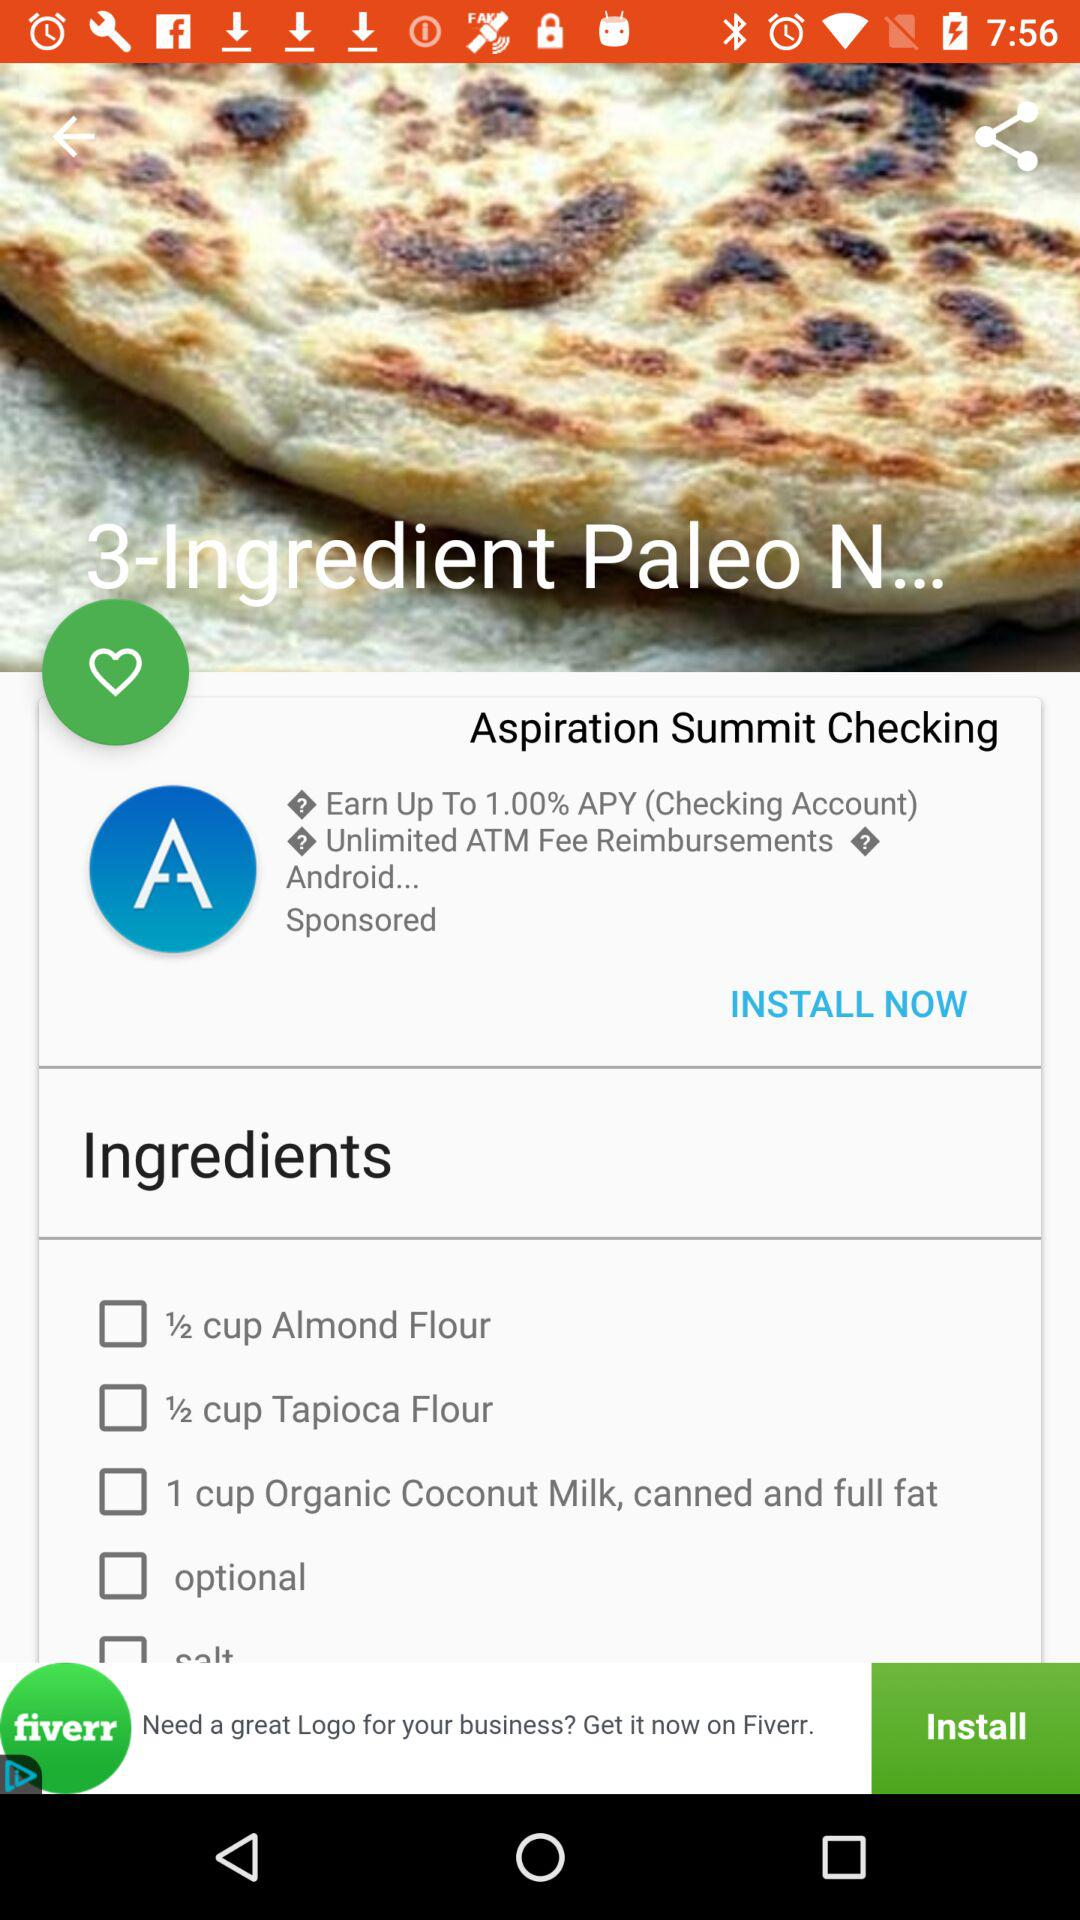How many ingredients are there in the recipe?
Answer the question using a single word or phrase. 5 